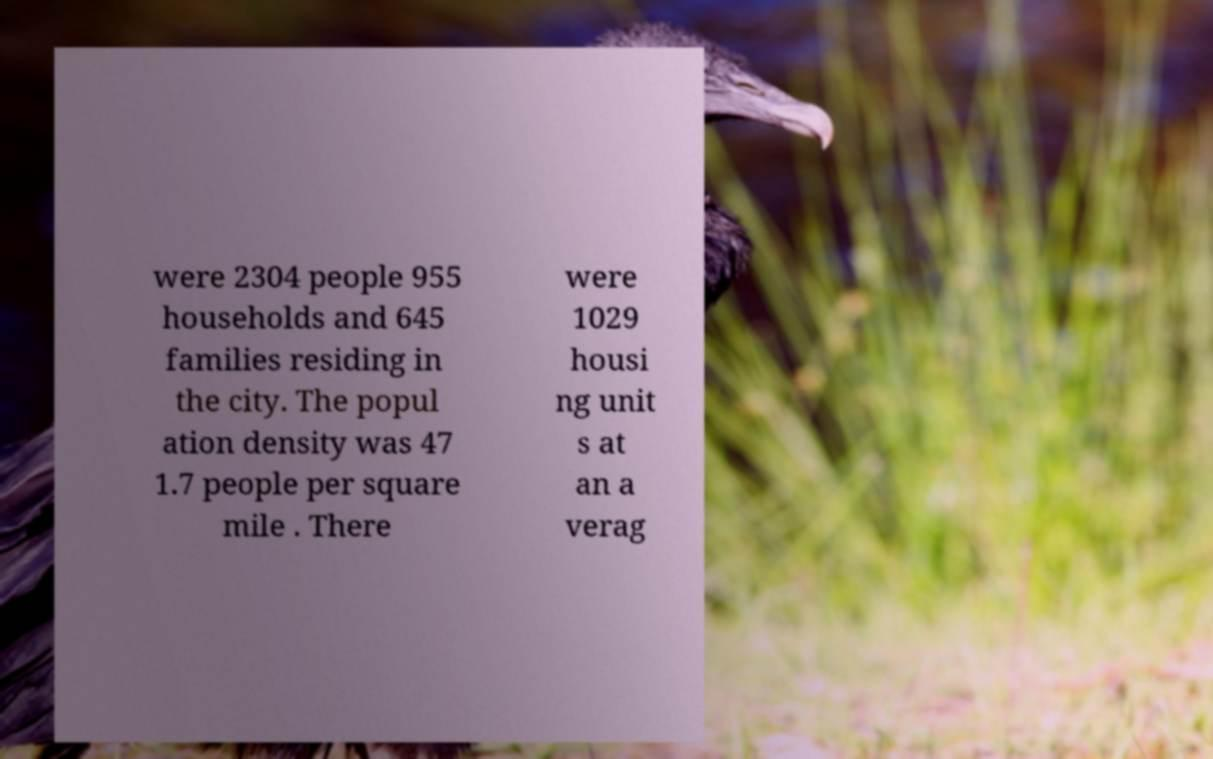Could you extract and type out the text from this image? were 2304 people 955 households and 645 families residing in the city. The popul ation density was 47 1.7 people per square mile . There were 1029 housi ng unit s at an a verag 